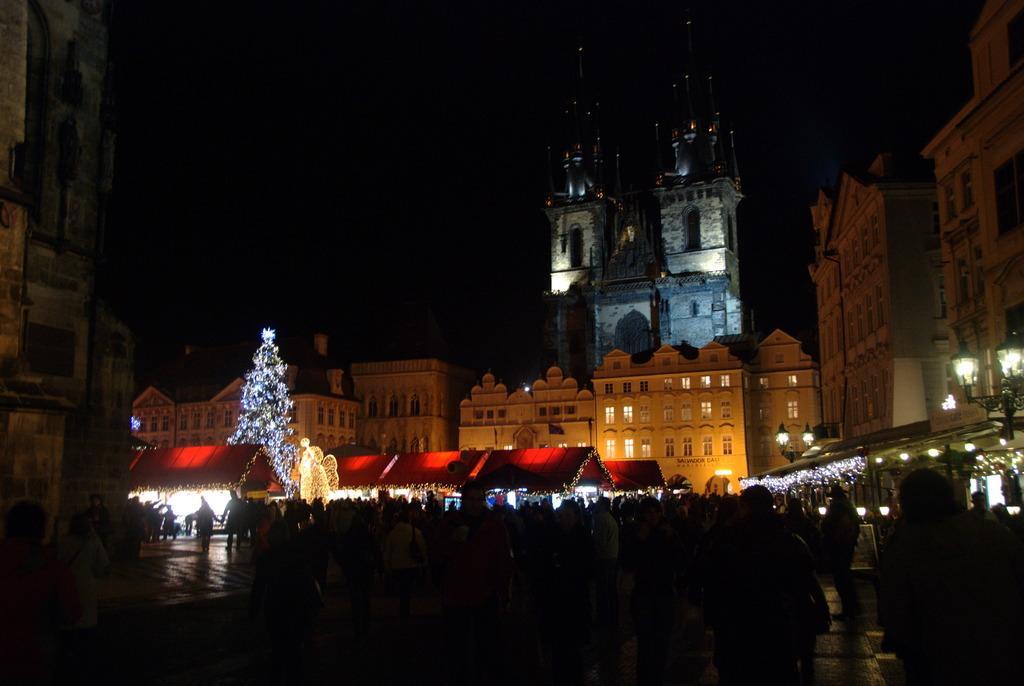Describe this image in one or two sentences. In this image I can see few buildings, few lights, few red colour tents and I can see a tree. I can see this image is little bit in dark. I can also see few more lights as decoration. 